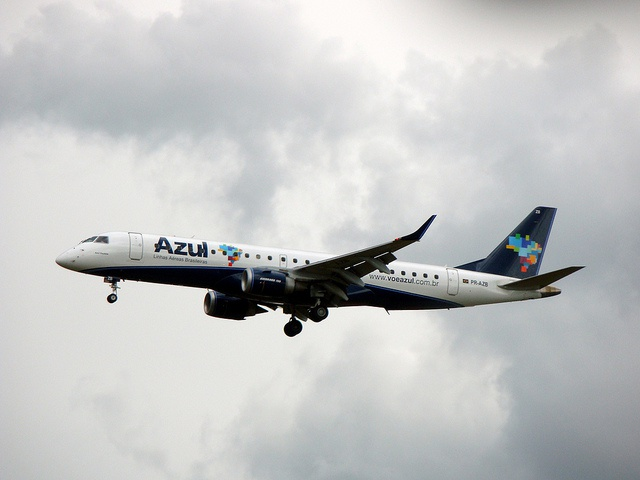Describe the objects in this image and their specific colors. I can see a airplane in lightgray, black, darkgray, and gray tones in this image. 